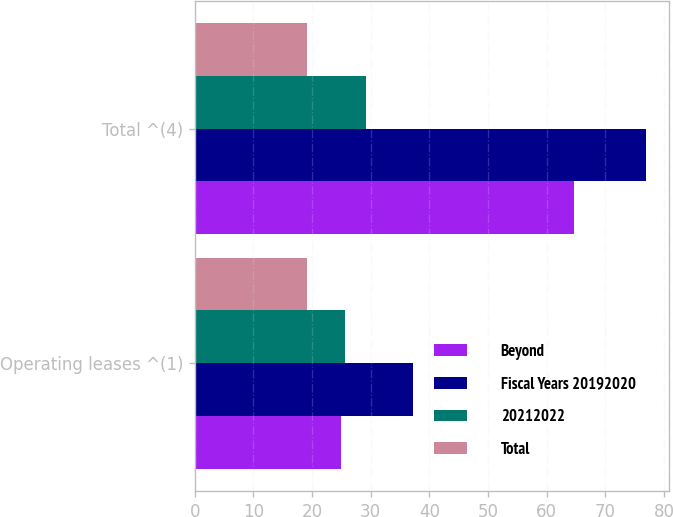Convert chart to OTSL. <chart><loc_0><loc_0><loc_500><loc_500><stacked_bar_chart><ecel><fcel>Operating leases ^(1)<fcel>Total ^(4)<nl><fcel>Beyond<fcel>24.9<fcel>64.6<nl><fcel>Fiscal Years 20192020<fcel>37.3<fcel>77<nl><fcel>20212022<fcel>25.6<fcel>29.2<nl><fcel>Total<fcel>19.1<fcel>19.1<nl></chart> 